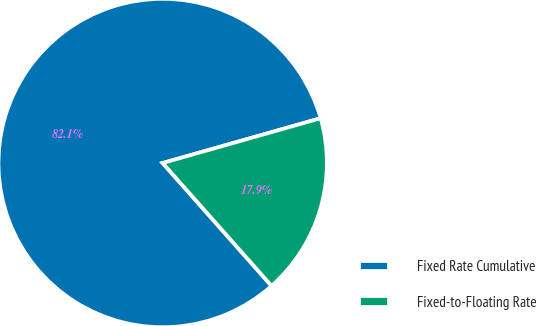Convert chart to OTSL. <chart><loc_0><loc_0><loc_500><loc_500><pie_chart><fcel>Fixed Rate Cumulative<fcel>Fixed-to-Floating Rate<nl><fcel>82.14%<fcel>17.86%<nl></chart> 